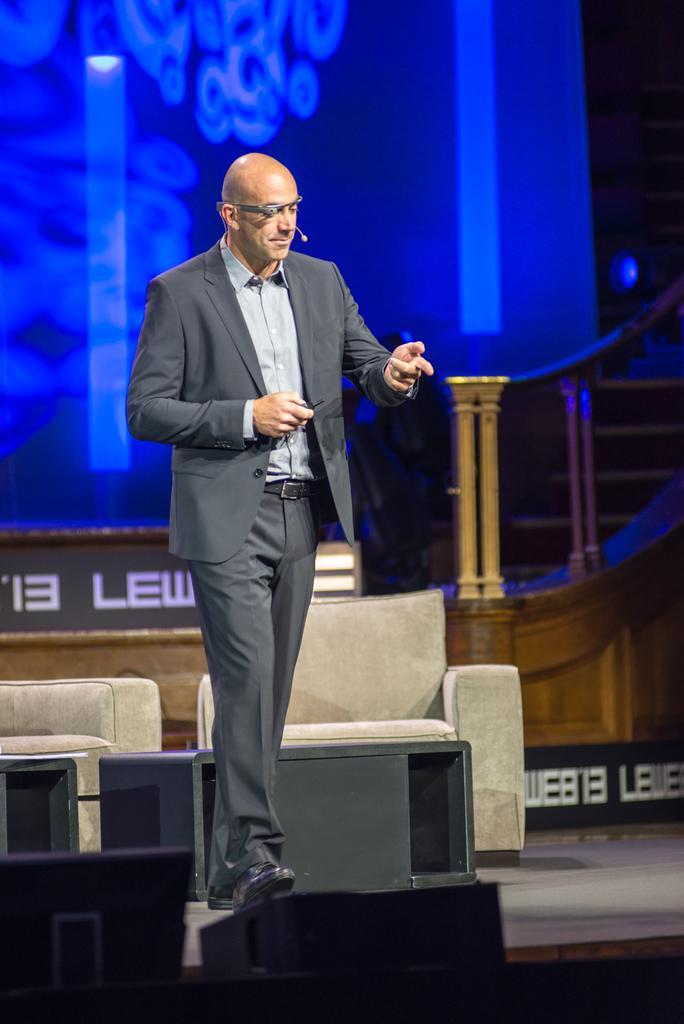Who is the main subject in the image? There is a person in the center of the image. What is the person wearing? The person is wearing a suit. What is the person doing in the image? The person is walking. What can be seen in the background of the image? There is a blue color screen, a staircase, and chairs in the background of the image. What type of planes can be seen flying in the morning in the image? There are no planes visible in the image, and the time of day is not mentioned. 